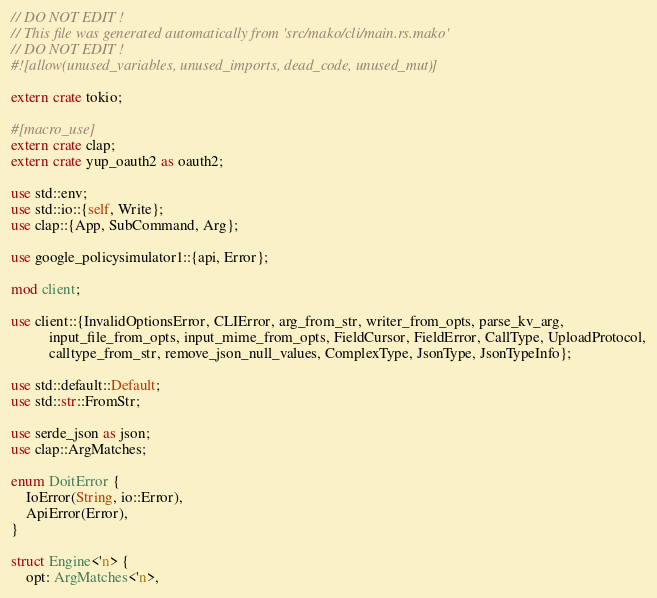Convert code to text. <code><loc_0><loc_0><loc_500><loc_500><_Rust_>// DO NOT EDIT !
// This file was generated automatically from 'src/mako/cli/main.rs.mako'
// DO NOT EDIT !
#![allow(unused_variables, unused_imports, dead_code, unused_mut)]

extern crate tokio;

#[macro_use]
extern crate clap;
extern crate yup_oauth2 as oauth2;

use std::env;
use std::io::{self, Write};
use clap::{App, SubCommand, Arg};

use google_policysimulator1::{api, Error};

mod client;

use client::{InvalidOptionsError, CLIError, arg_from_str, writer_from_opts, parse_kv_arg,
          input_file_from_opts, input_mime_from_opts, FieldCursor, FieldError, CallType, UploadProtocol,
          calltype_from_str, remove_json_null_values, ComplexType, JsonType, JsonTypeInfo};

use std::default::Default;
use std::str::FromStr;

use serde_json as json;
use clap::ArgMatches;

enum DoitError {
    IoError(String, io::Error),
    ApiError(Error),
}

struct Engine<'n> {
    opt: ArgMatches<'n>,</code> 